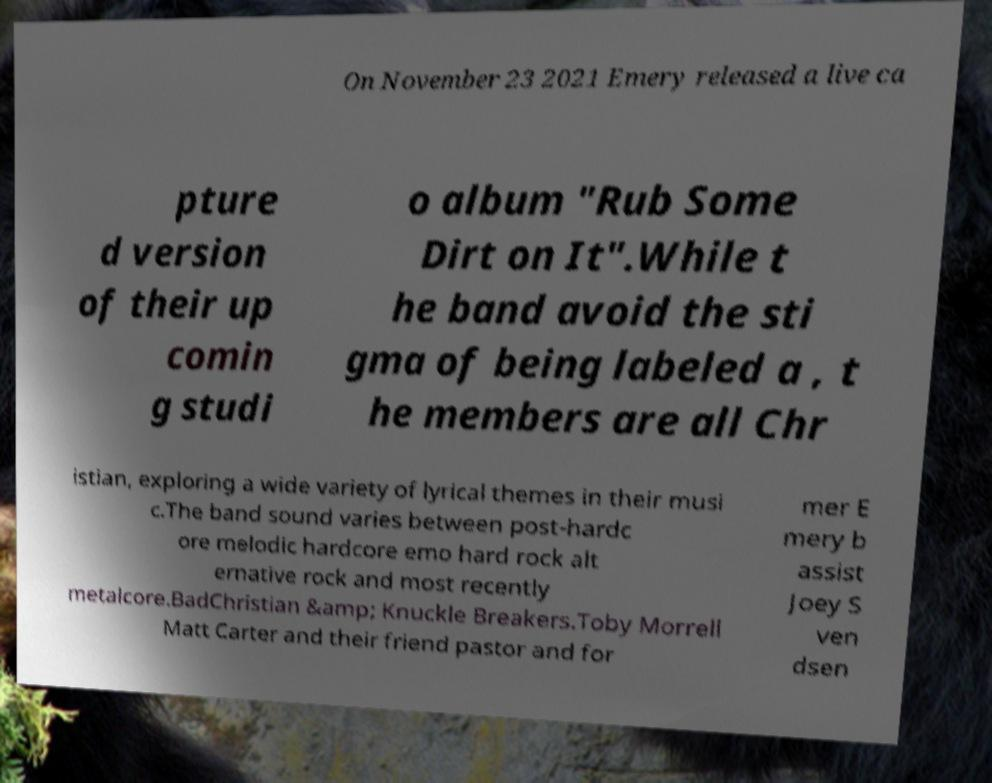Can you accurately transcribe the text from the provided image for me? On November 23 2021 Emery released a live ca pture d version of their up comin g studi o album "Rub Some Dirt on It".While t he band avoid the sti gma of being labeled a , t he members are all Chr istian, exploring a wide variety of lyrical themes in their musi c.The band sound varies between post-hardc ore melodic hardcore emo hard rock alt ernative rock and most recently metalcore.BadChristian &amp; Knuckle Breakers.Toby Morrell Matt Carter and their friend pastor and for mer E mery b assist Joey S ven dsen 